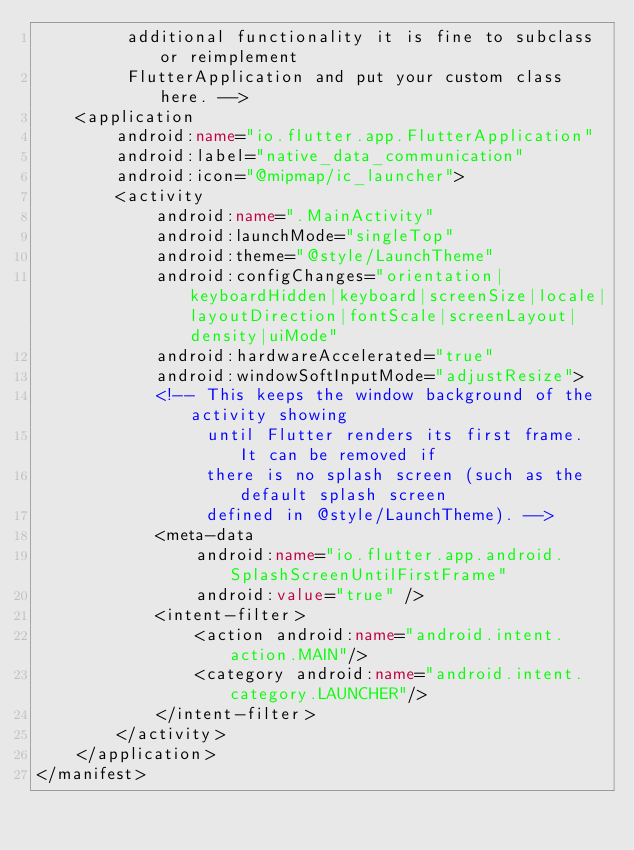<code> <loc_0><loc_0><loc_500><loc_500><_XML_>         additional functionality it is fine to subclass or reimplement
         FlutterApplication and put your custom class here. -->
    <application
        android:name="io.flutter.app.FlutterApplication"
        android:label="native_data_communication"
        android:icon="@mipmap/ic_launcher">
        <activity
            android:name=".MainActivity"
            android:launchMode="singleTop"
            android:theme="@style/LaunchTheme"
            android:configChanges="orientation|keyboardHidden|keyboard|screenSize|locale|layoutDirection|fontScale|screenLayout|density|uiMode"
            android:hardwareAccelerated="true"
            android:windowSoftInputMode="adjustResize">
            <!-- This keeps the window background of the activity showing
                 until Flutter renders its first frame. It can be removed if
                 there is no splash screen (such as the default splash screen
                 defined in @style/LaunchTheme). -->
            <meta-data
                android:name="io.flutter.app.android.SplashScreenUntilFirstFrame"
                android:value="true" />
            <intent-filter>
                <action android:name="android.intent.action.MAIN"/>
                <category android:name="android.intent.category.LAUNCHER"/>
            </intent-filter>
        </activity>
    </application>
</manifest>
</code> 